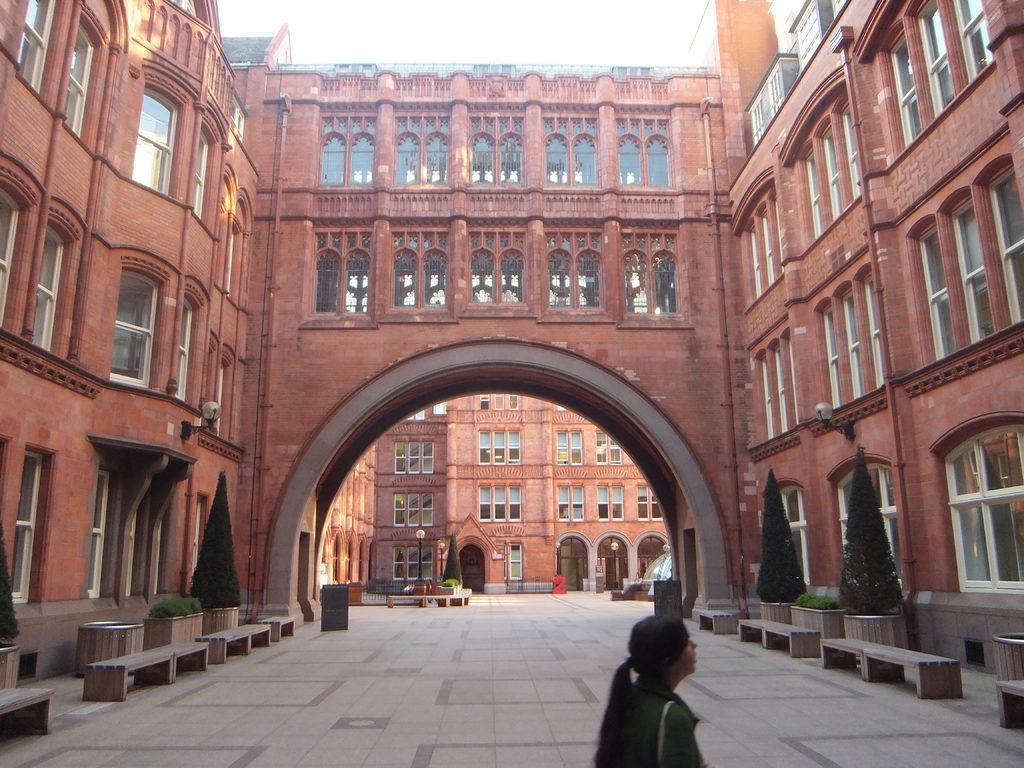Can you describe this image briefly? In this image, we can see buildings, lights, shrubs, plants, benches and there is a lady wearing a bag. At the bottom, there is a floor. 